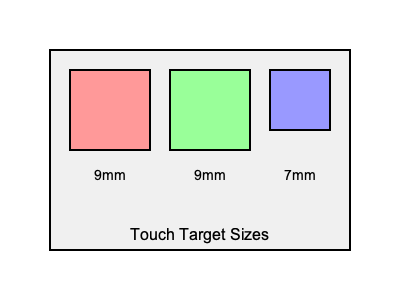Based on the image showing different touch target sizes, which size is considered optimal for most mobile interfaces to ensure good usability and minimize user frustration? To determine the optimal touch target size for mobile interfaces, we need to consider several factors:

1. Human finger size: The average adult fingertip is about 8-10mm wide.

2. Accuracy: Larger touch targets are easier to tap accurately, reducing errors and user frustration.

3. Screen real estate: Touch targets shouldn't be so large that they waste screen space or limit the number of elements that can be displayed.

4. Accessibility guidelines: The Web Content Accessibility Guidelines (WCAG) recommend a minimum touch target size of 44x44 pixels.

5. Industry standards: Major mobile platforms have their own guidelines:
   - Apple recommends a minimum target size of 44x44 points (approximately 9mm).
   - Google recommends touch targets be at least 48x48 dp (density-independent pixels, approximately 9mm).

6. Research findings: Studies have shown that touch targets between 9-10mm offer a good balance between accuracy and screen space utilization.

Looking at the image:
- The 9mm touch targets (red and green squares) align with industry recommendations and research findings.
- The 7mm touch target (blue square) is smaller than recommended and may lead to more errors and user frustration.

Therefore, the 9mm touch target size is considered optimal for most mobile interfaces, as it provides a good balance between usability, accuracy, and efficient use of screen space.
Answer: 9mm 